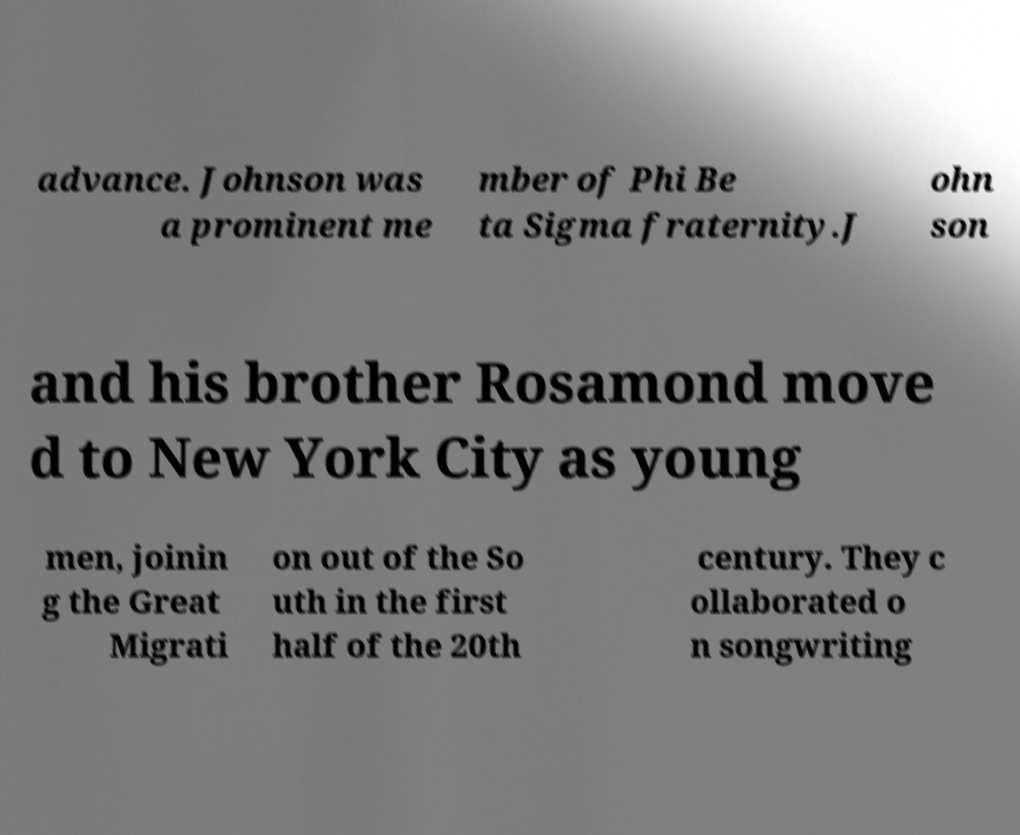What messages or text are displayed in this image? I need them in a readable, typed format. advance. Johnson was a prominent me mber of Phi Be ta Sigma fraternity.J ohn son and his brother Rosamond move d to New York City as young men, joinin g the Great Migrati on out of the So uth in the first half of the 20th century. They c ollaborated o n songwriting 